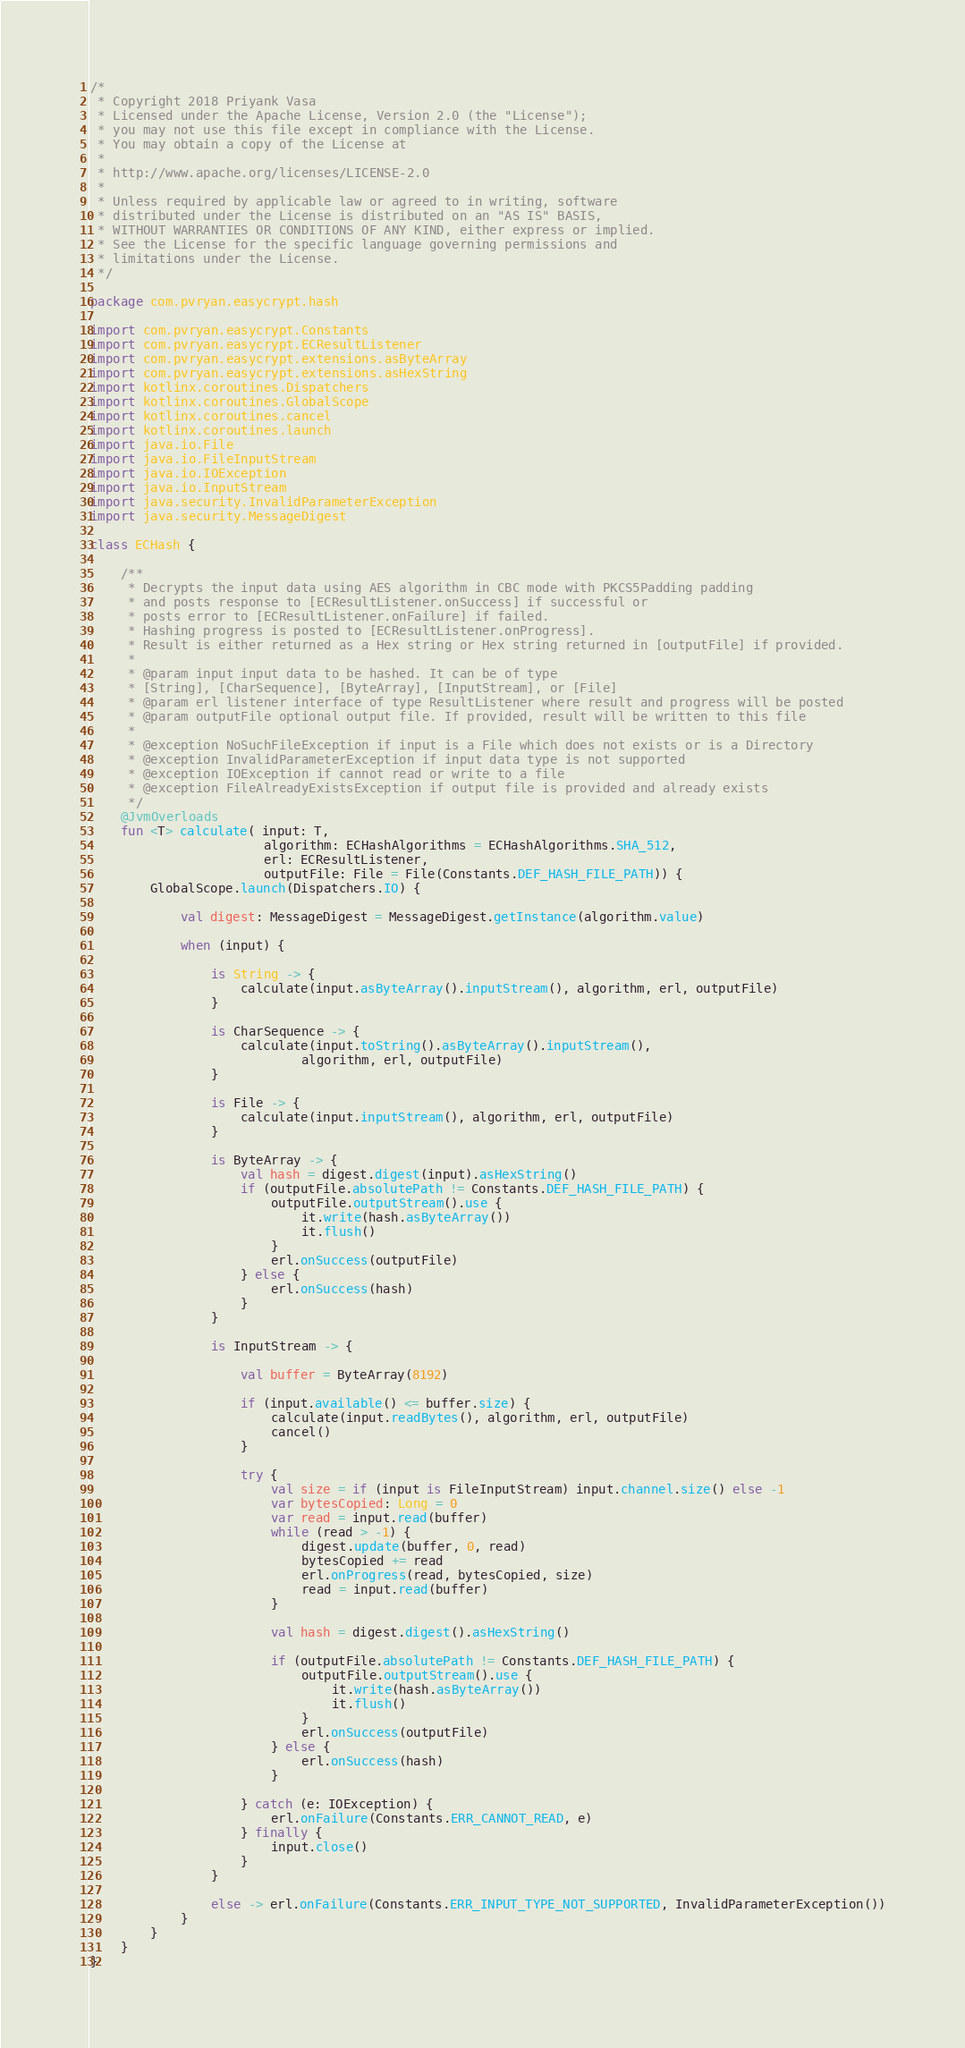<code> <loc_0><loc_0><loc_500><loc_500><_Kotlin_>/*
 * Copyright 2018 Priyank Vasa
 * Licensed under the Apache License, Version 2.0 (the "License");
 * you may not use this file except in compliance with the License.
 * You may obtain a copy of the License at
 *
 * http://www.apache.org/licenses/LICENSE-2.0
 *
 * Unless required by applicable law or agreed to in writing, software
 * distributed under the License is distributed on an "AS IS" BASIS,
 * WITHOUT WARRANTIES OR CONDITIONS OF ANY KIND, either express or implied.
 * See the License for the specific language governing permissions and
 * limitations under the License.
 */

package com.pvryan.easycrypt.hash

import com.pvryan.easycrypt.Constants
import com.pvryan.easycrypt.ECResultListener
import com.pvryan.easycrypt.extensions.asByteArray
import com.pvryan.easycrypt.extensions.asHexString
import kotlinx.coroutines.Dispatchers
import kotlinx.coroutines.GlobalScope
import kotlinx.coroutines.cancel
import kotlinx.coroutines.launch
import java.io.File
import java.io.FileInputStream
import java.io.IOException
import java.io.InputStream
import java.security.InvalidParameterException
import java.security.MessageDigest

class ECHash {

    /**
     * Decrypts the input data using AES algorithm in CBC mode with PKCS5Padding padding
     * and posts response to [ECResultListener.onSuccess] if successful or
     * posts error to [ECResultListener.onFailure] if failed.
     * Hashing progress is posted to [ECResultListener.onProgress].
     * Result is either returned as a Hex string or Hex string returned in [outputFile] if provided.
     *
     * @param input input data to be hashed. It can be of type
     * [String], [CharSequence], [ByteArray], [InputStream], or [File]
     * @param erl listener interface of type ResultListener where result and progress will be posted
     * @param outputFile optional output file. If provided, result will be written to this file
     *
     * @exception NoSuchFileException if input is a File which does not exists or is a Directory
     * @exception InvalidParameterException if input data type is not supported
     * @exception IOException if cannot read or write to a file
     * @exception FileAlreadyExistsException if output file is provided and already exists
     */
    @JvmOverloads
    fun <T> calculate( input: T,
                       algorithm: ECHashAlgorithms = ECHashAlgorithms.SHA_512,
                       erl: ECResultListener,
                       outputFile: File = File(Constants.DEF_HASH_FILE_PATH)) {
        GlobalScope.launch(Dispatchers.IO) {

            val digest: MessageDigest = MessageDigest.getInstance(algorithm.value)

            when (input) {

                is String -> {
                    calculate(input.asByteArray().inputStream(), algorithm, erl, outputFile)
                }

                is CharSequence -> {
                    calculate(input.toString().asByteArray().inputStream(),
                            algorithm, erl, outputFile)
                }

                is File -> {
                    calculate(input.inputStream(), algorithm, erl, outputFile)
                }

                is ByteArray -> {
                    val hash = digest.digest(input).asHexString()
                    if (outputFile.absolutePath != Constants.DEF_HASH_FILE_PATH) {
                        outputFile.outputStream().use {
                            it.write(hash.asByteArray())
                            it.flush()
                        }
                        erl.onSuccess(outputFile)
                    } else {
                        erl.onSuccess(hash)
                    }
                }

                is InputStream -> {

                    val buffer = ByteArray(8192)

                    if (input.available() <= buffer.size) {
                        calculate(input.readBytes(), algorithm, erl, outputFile)
                        cancel()
                    }

                    try {
                        val size = if (input is FileInputStream) input.channel.size() else -1
                        var bytesCopied: Long = 0
                        var read = input.read(buffer)
                        while (read > -1) {
                            digest.update(buffer, 0, read)
                            bytesCopied += read
                            erl.onProgress(read, bytesCopied, size)
                            read = input.read(buffer)
                        }

                        val hash = digest.digest().asHexString()

                        if (outputFile.absolutePath != Constants.DEF_HASH_FILE_PATH) {
                            outputFile.outputStream().use {
                                it.write(hash.asByteArray())
                                it.flush()
                            }
                            erl.onSuccess(outputFile)
                        } else {
                            erl.onSuccess(hash)
                        }

                    } catch (e: IOException) {
                        erl.onFailure(Constants.ERR_CANNOT_READ, e)
                    } finally {
                        input.close()
                    }
                }

                else -> erl.onFailure(Constants.ERR_INPUT_TYPE_NOT_SUPPORTED, InvalidParameterException())
            }
        }
    }
}</code> 